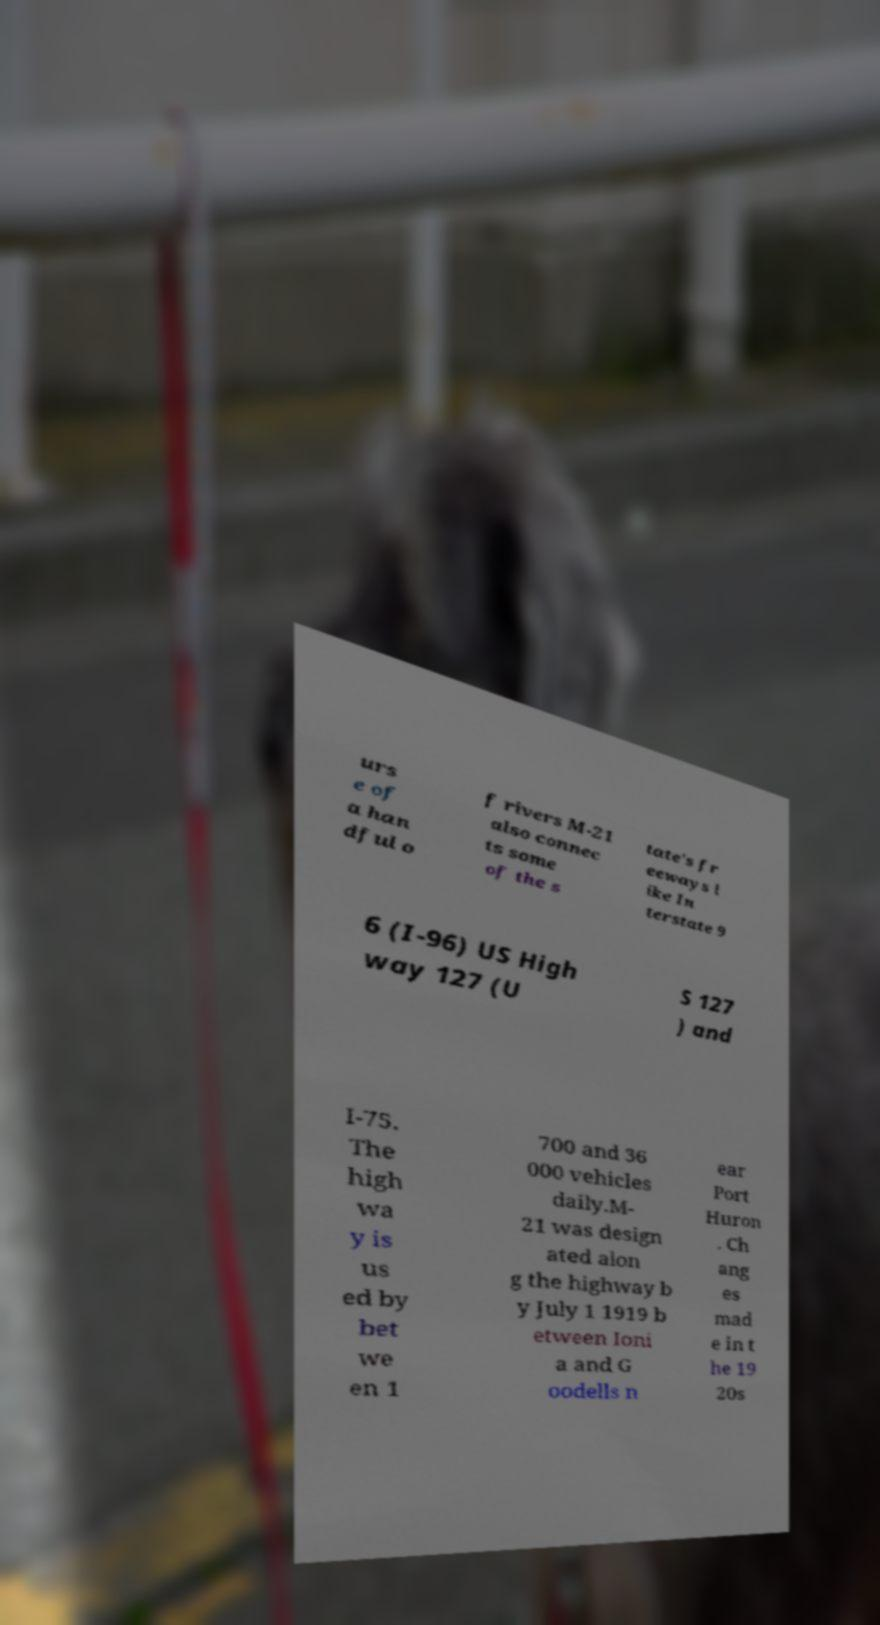Please read and relay the text visible in this image. What does it say? urs e of a han dful o f rivers M-21 also connec ts some of the s tate's fr eeways l ike In terstate 9 6 (I-96) US High way 127 (U S 127 ) and I-75. The high wa y is us ed by bet we en 1 700 and 36 000 vehicles daily.M- 21 was design ated alon g the highway b y July 1 1919 b etween Ioni a and G oodells n ear Port Huron . Ch ang es mad e in t he 19 20s 